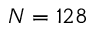<formula> <loc_0><loc_0><loc_500><loc_500>N = 1 2 8</formula> 